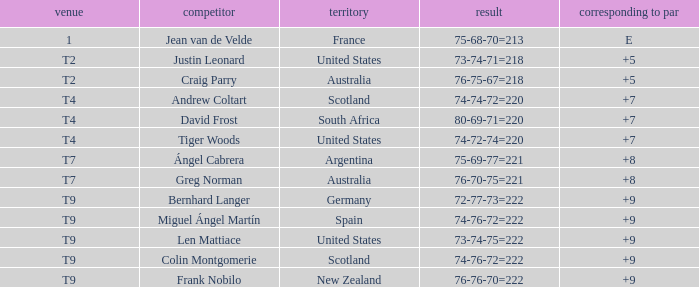Which player from the United States is in a place of T2? Justin Leonard. 